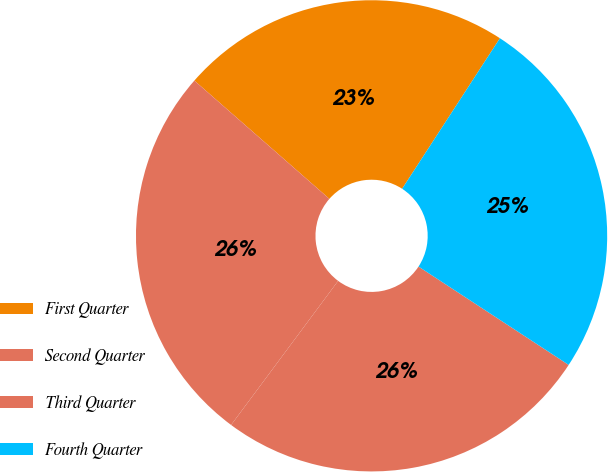Convert chart to OTSL. <chart><loc_0><loc_0><loc_500><loc_500><pie_chart><fcel>First Quarter<fcel>Second Quarter<fcel>Third Quarter<fcel>Fourth Quarter<nl><fcel>22.72%<fcel>26.28%<fcel>25.94%<fcel>25.06%<nl></chart> 